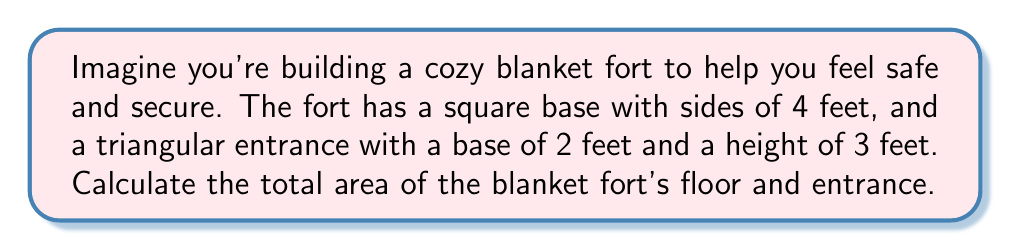Solve this math problem. Let's break this problem down into steps:

1. Calculate the area of the square base:
   The area of a square is given by the formula $A = s^2$, where $s$ is the length of a side.
   $$A_{base} = 4^2 = 16 \text{ sq ft}$$

2. Calculate the area of the triangular entrance:
   The area of a triangle is given by the formula $A = \frac{1}{2} \times b \times h$, where $b$ is the base and $h$ is the height.
   $$A_{entrance} = \frac{1}{2} \times 2 \times 3 = 3 \text{ sq ft}$$

3. Sum up the total area:
   $$A_{total} = A_{base} + A_{entrance} = 16 + 3 = 19 \text{ sq ft}$$

[asy]
unitsize(20);
fill((0,0)--(4,0)--(4,4)--(0,4)--cycle, gray(0.9));
draw((0,0)--(4,0)--(4,4)--(0,4)--cycle);
label("4 ft", (2,0), S);
label("4 ft", (4,2), E);
fill((1,0)--(3,0)--(2,3)--cycle, gray(0.7));
draw((1,0)--(3,0)--(2,3)--cycle);
label("2 ft", (2,0), N);
label("3 ft", (2,1.5), E);
[/asy]
Answer: 19 sq ft 